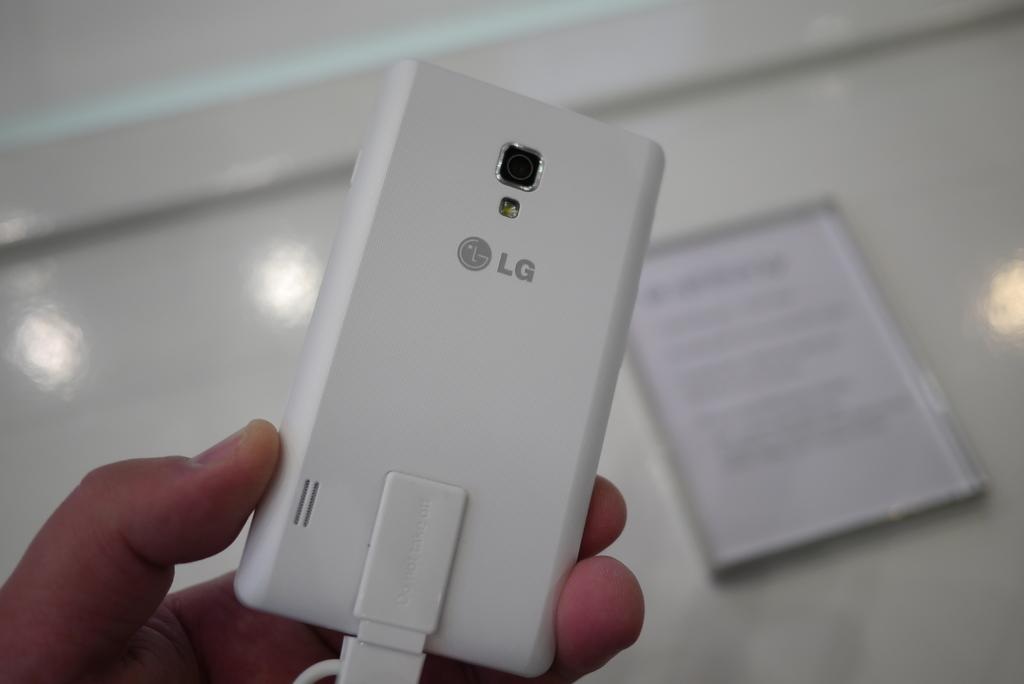<image>
Describe the image concisely. An LG electronic device in a human hand. 